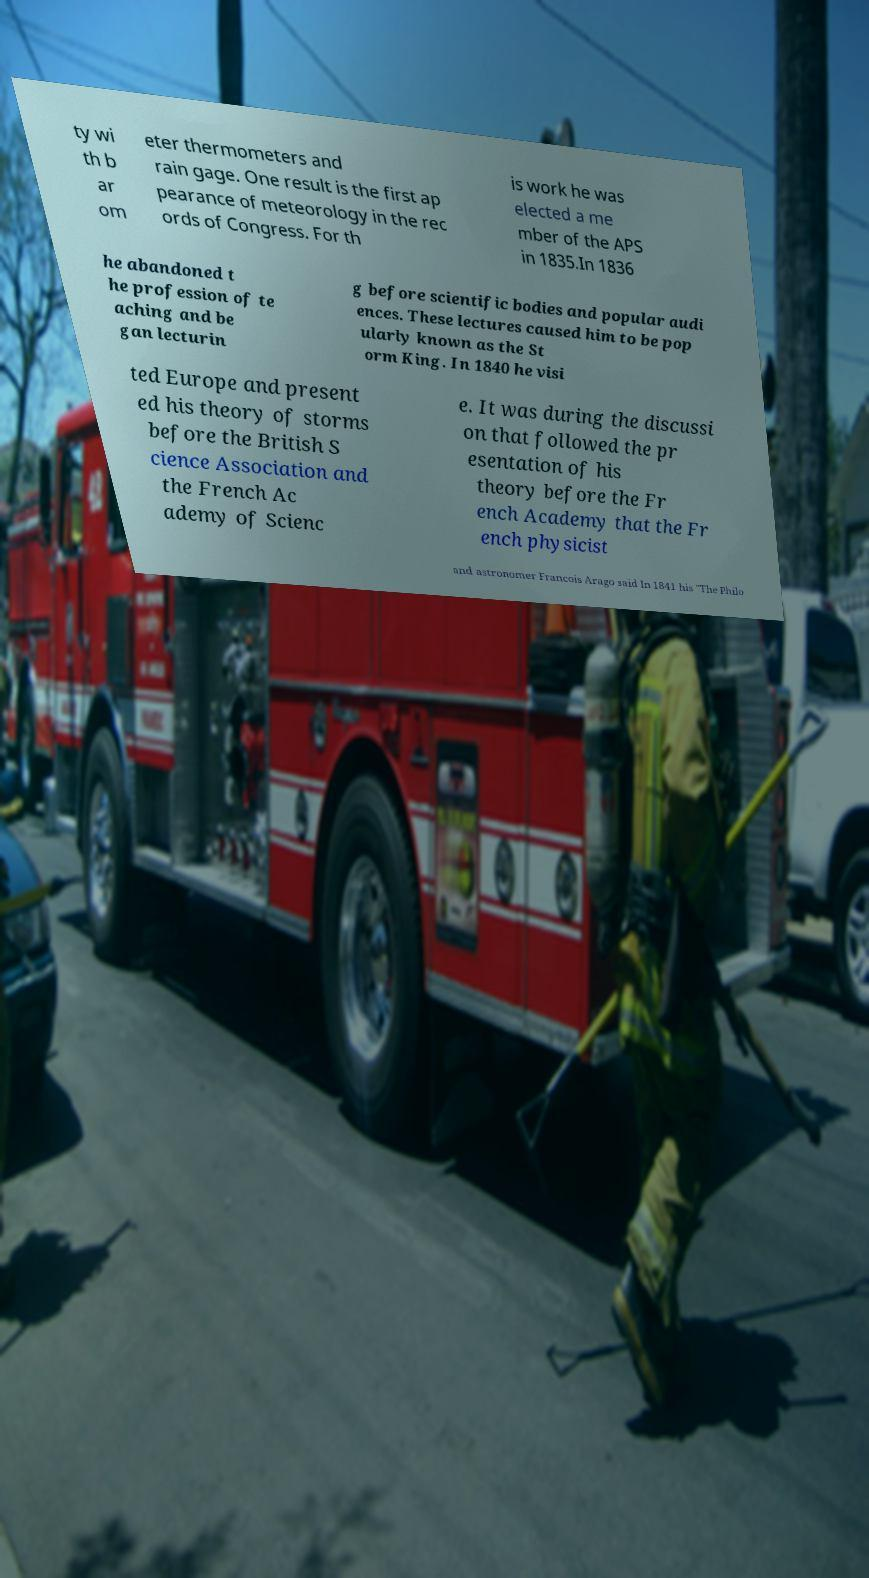Can you accurately transcribe the text from the provided image for me? ty wi th b ar om eter thermometers and rain gage. One result is the first ap pearance of meteorology in the rec ords of Congress. For th is work he was elected a me mber of the APS in 1835.In 1836 he abandoned t he profession of te aching and be gan lecturin g before scientific bodies and popular audi ences. These lectures caused him to be pop ularly known as the St orm King. In 1840 he visi ted Europe and present ed his theory of storms before the British S cience Association and the French Ac ademy of Scienc e. It was during the discussi on that followed the pr esentation of his theory before the Fr ench Academy that the Fr ench physicist and astronomer Francois Arago said In 1841 his "The Philo 